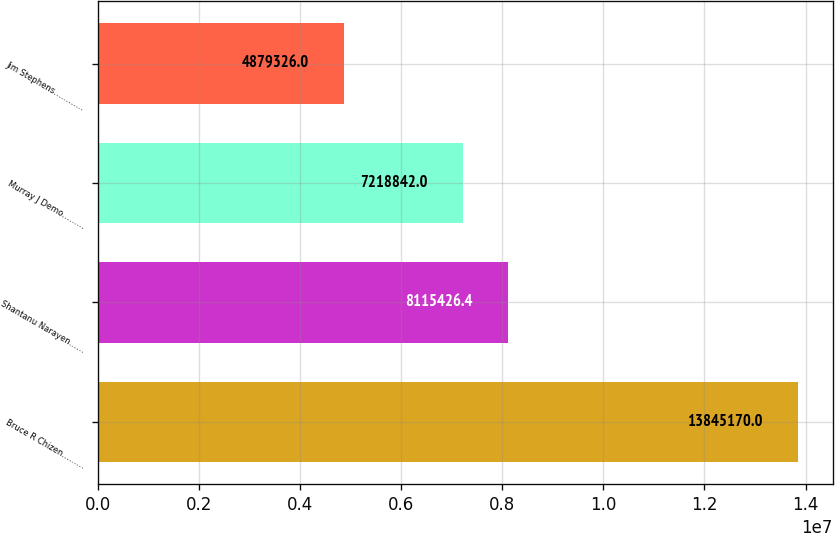Convert chart. <chart><loc_0><loc_0><loc_500><loc_500><bar_chart><fcel>Bruce R Chizen………<fcel>Shantanu Narayen……<fcel>Murray J Demo………<fcel>Jim Stephens…………<nl><fcel>1.38452e+07<fcel>8.11543e+06<fcel>7.21884e+06<fcel>4.87933e+06<nl></chart> 